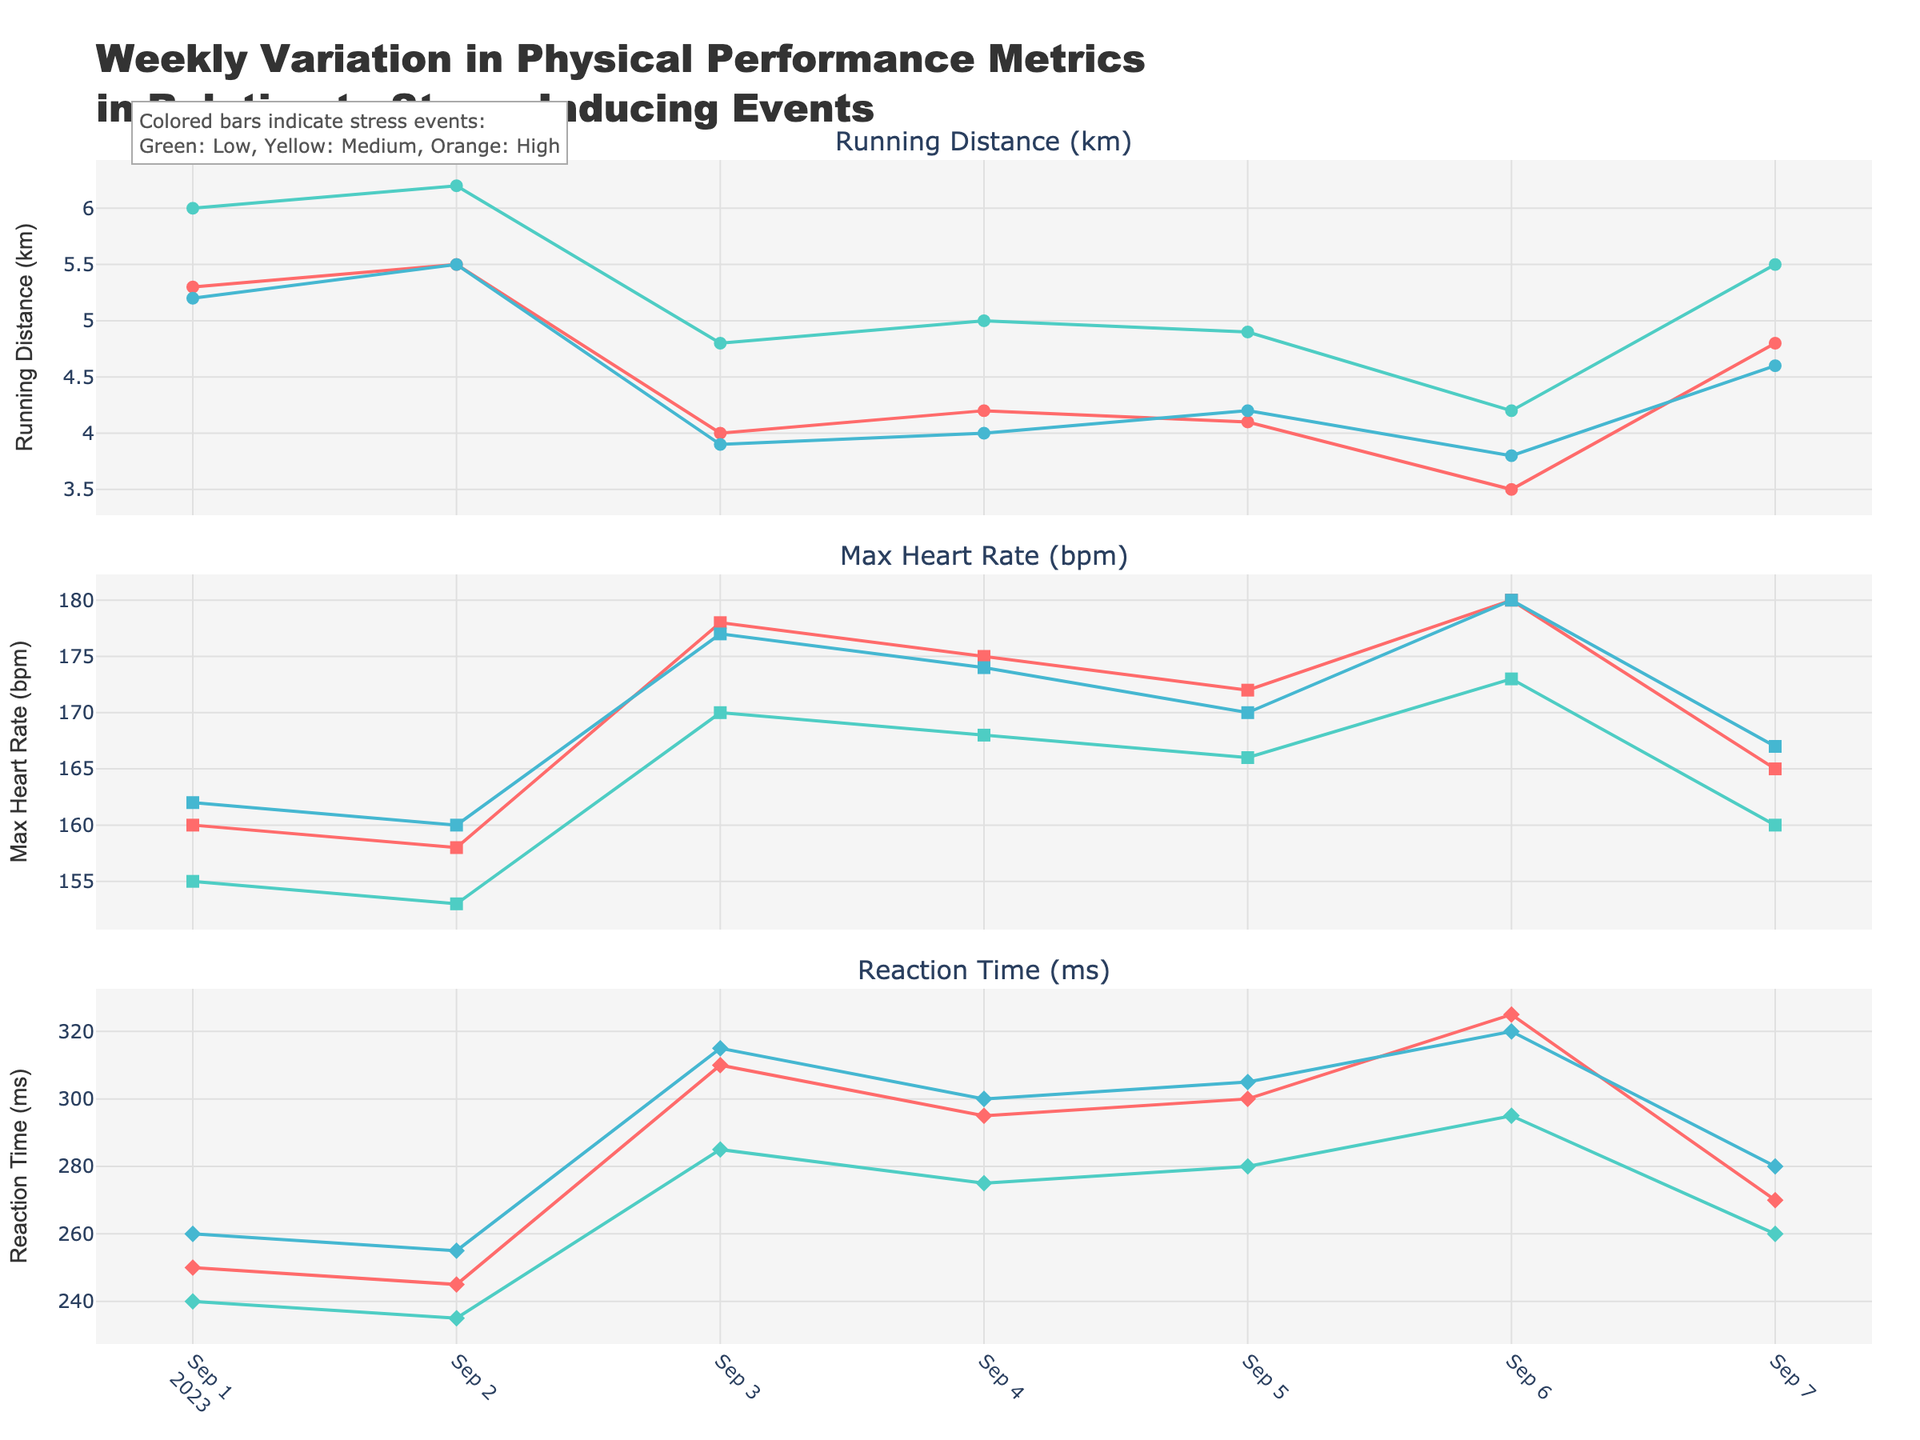What's the title of the figure? The title is located at the top of the figure and is the largest text present, describing the content of the visualization.
Answer: Weekly Variation in Physical Performance Metrics in Relation to Stress-Inducing Events How many subjects are represented in the figure? By examining the legend and the distinct colors and marker types, we can see there are three subjects represented.
Answer: 3 On which date did Subject_01 have the lowest running distance? Look at the running distance subplot and find the lowest point for Subject_01's traces. This occurs on 2023-09-06.
Answer: 2023-09-06 What was the reaction time of Subject_02 on the day the exam was announced? Locate the date 2023-09-03 in the reaction time subplot and check the data point for Subject_02 on that date.
Answer: 285 ms Compare the maximum heart rate of Subject_03 on the exam announcement date and the major project deadline date. Which date had a higher max heart rate? Locate both dates (2023-09-03 and 2023-09-06) for Subject_03 in the max heart rate subplot. Compare the values, 177 bpm (exam) vs. 180 bpm (project).
Answer: 2023-09-06 What is the average running distance for Subject_02 over the week? Add the running distances for each date for Subject_02, then divide by the number of dates (6.0 + 6.2 + 4.8 + 5.0 + 4.9 + 4.2 + 5.5) / 7.
Answer: 5.23 km Which subject showed the highest variability in heart rate throughout the week? Evaluate the max and min heart rates for each subject. Calculating the range: Subject_01 (180-158), Subject_02 (173-153), Subject_03 (180-160).
Answer: Subject_03 On which dates did all three subjects experience high-stress events? Identify dates with colored indicators in all three subplots for all subjects. The dates are 2023-09-03 and 2023-09-06.
Answer: 2023-09-03, 2023-09-06 Between 2023-09-03 and 2023-09-04, did any subjects show an improvement in their reaction time? Examine the reaction time subplot for each subject from 2023-09-03 to 2023-09-04 and check if any values decreased.
Answer: Subject_01, Subject_02, Subject_03 